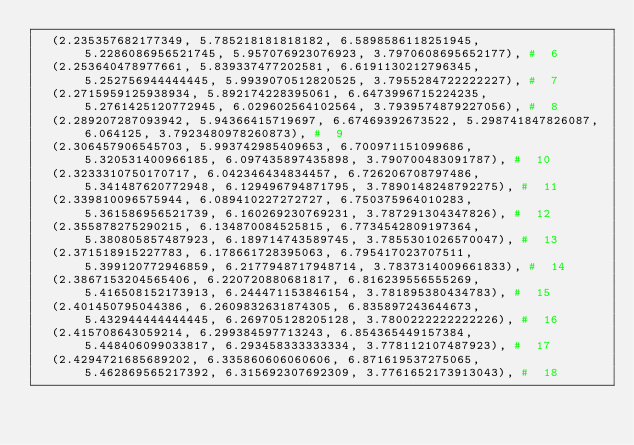<code> <loc_0><loc_0><loc_500><loc_500><_Python_>	(2.235357682177349, 5.785218181818182, 6.5898586118251945, 5.2286086956521745, 5.957076923076923, 3.7970608695652177), #  6
	(2.253640478977661, 5.839337477202581, 6.6191130212796345, 5.252756944444445, 5.9939070512820525, 3.7955284722222227), #  7
	(2.2715959125938934, 5.892174228395061, 6.6473996715224235, 5.2761425120772945, 6.029602564102564, 3.7939574879227056), #  8
	(2.289207287093942, 5.94366415719697, 6.67469392673522, 5.298741847826087, 6.064125, 3.7923480978260873), #  9
	(2.306457906545703, 5.993742985409653, 6.700971151099686, 5.320531400966185, 6.097435897435898, 3.790700483091787), #  10
	(2.3233310750170717, 6.042346434834457, 6.726206708797486, 5.341487620772948, 6.129496794871795, 3.7890148248792275), #  11
	(2.339810096575944, 6.089410227272727, 6.750375964010283, 5.361586956521739, 6.160269230769231, 3.787291304347826), #  12
	(2.355878275290215, 6.134870084525815, 6.7734542809197364, 5.380805857487923, 6.189714743589745, 3.7855301026570047), #  13
	(2.371518915227783, 6.178661728395063, 6.795417023707511, 5.399120772946859, 6.2177948717948714, 3.7837314009661833), #  14
	(2.3867153204565406, 6.220720880681817, 6.816239556555269, 5.416508152173913, 6.244471153846154, 3.781895380434783), #  15
	(2.401450795044386, 6.2609832631874305, 6.835897243644673, 5.432944444444445, 6.269705128205128, 3.7800222222222226), #  16
	(2.415708643059214, 6.299384597713243, 6.854365449157384, 5.448406099033817, 6.293458333333334, 3.778112107487923), #  17
	(2.4294721685689202, 6.335860606060606, 6.871619537275065, 5.462869565217392, 6.315692307692309, 3.7761652173913043), #  18</code> 